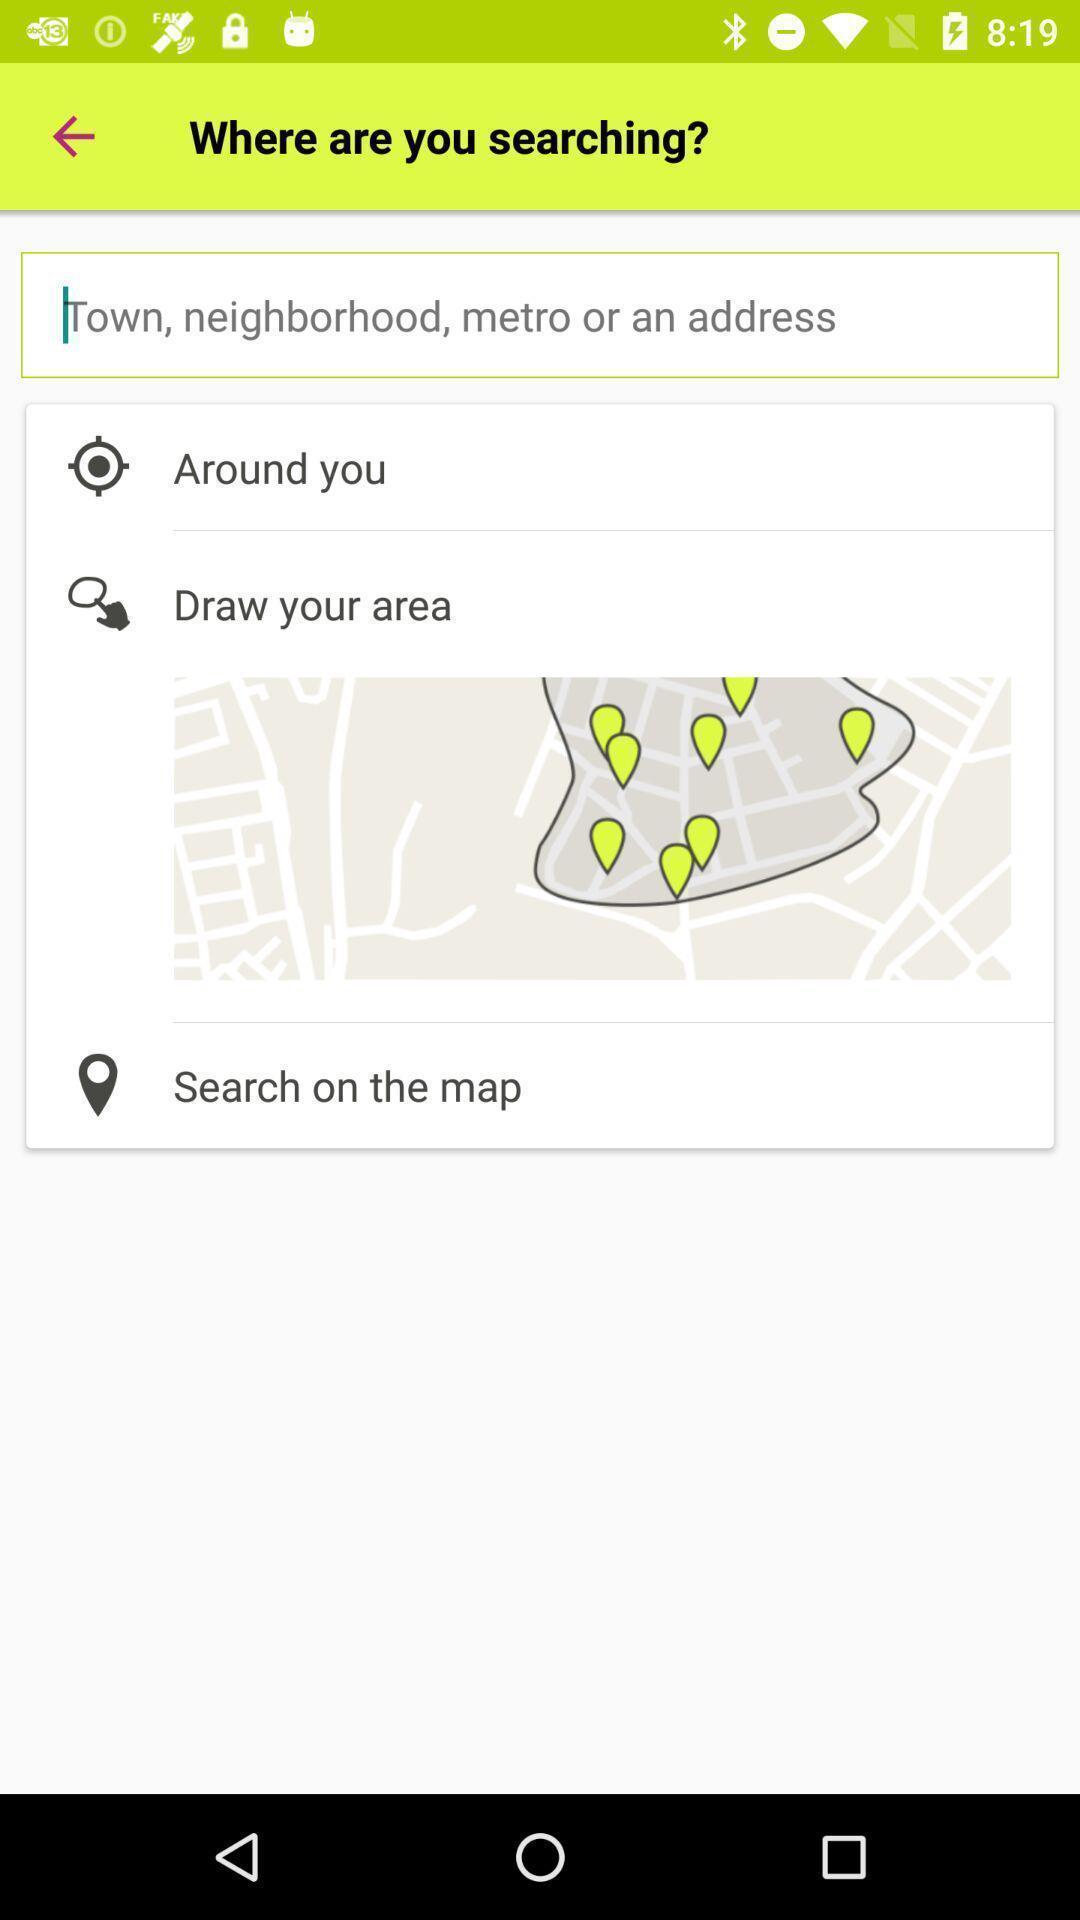Give me a summary of this screen capture. Search page for searching a location. 